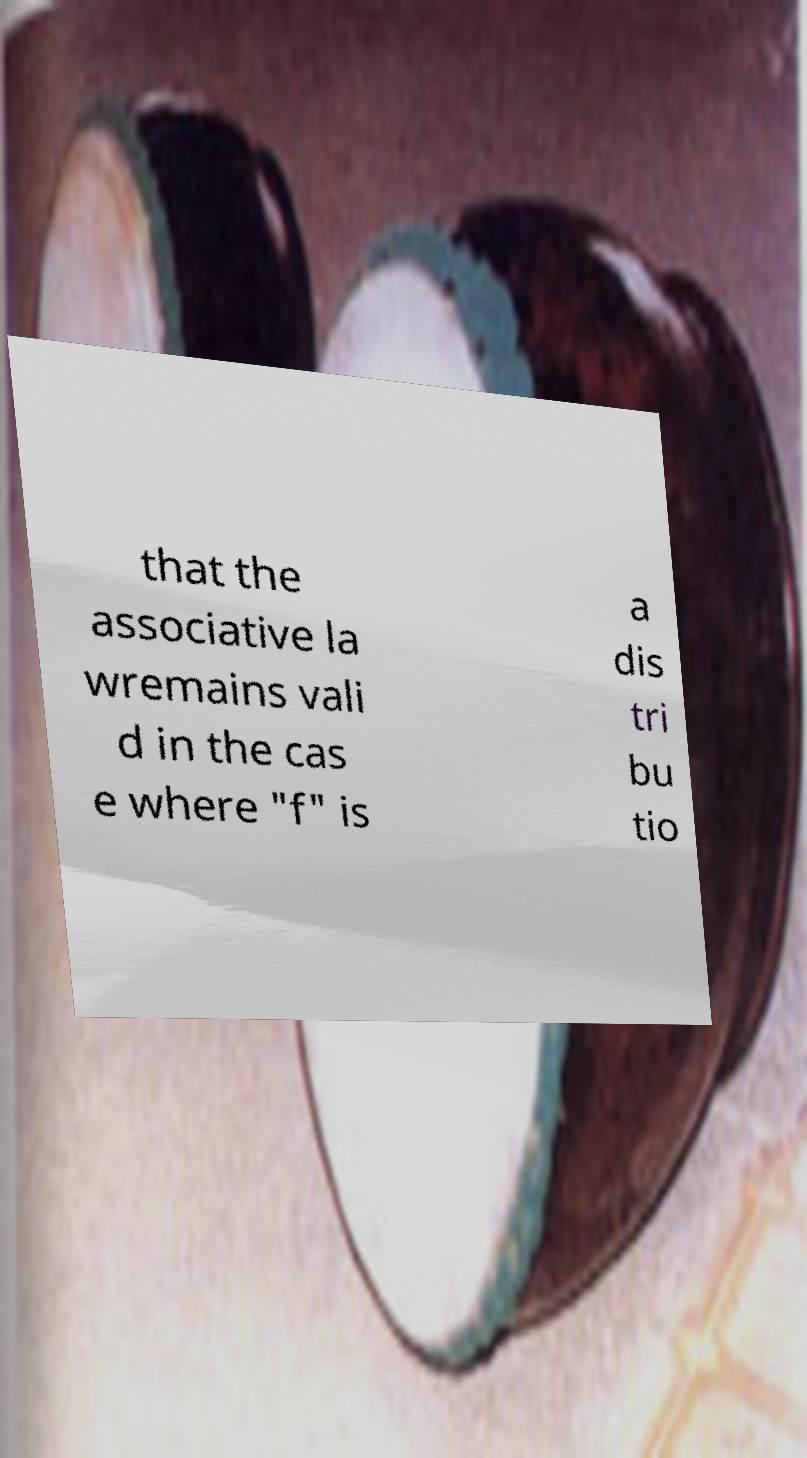Please identify and transcribe the text found in this image. that the associative la wremains vali d in the cas e where "f" is a dis tri bu tio 